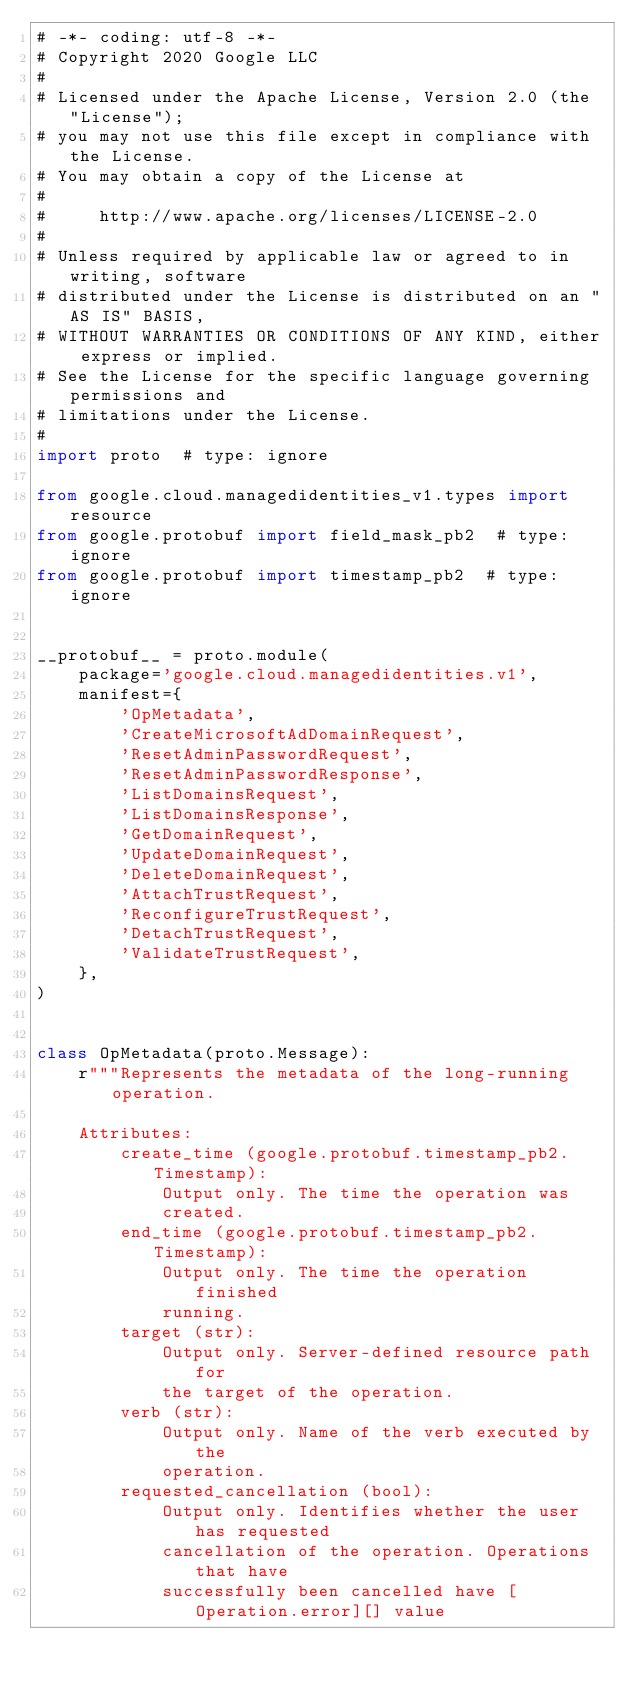Convert code to text. <code><loc_0><loc_0><loc_500><loc_500><_Python_># -*- coding: utf-8 -*-
# Copyright 2020 Google LLC
#
# Licensed under the Apache License, Version 2.0 (the "License");
# you may not use this file except in compliance with the License.
# You may obtain a copy of the License at
#
#     http://www.apache.org/licenses/LICENSE-2.0
#
# Unless required by applicable law or agreed to in writing, software
# distributed under the License is distributed on an "AS IS" BASIS,
# WITHOUT WARRANTIES OR CONDITIONS OF ANY KIND, either express or implied.
# See the License for the specific language governing permissions and
# limitations under the License.
#
import proto  # type: ignore

from google.cloud.managedidentities_v1.types import resource
from google.protobuf import field_mask_pb2  # type: ignore
from google.protobuf import timestamp_pb2  # type: ignore


__protobuf__ = proto.module(
    package='google.cloud.managedidentities.v1',
    manifest={
        'OpMetadata',
        'CreateMicrosoftAdDomainRequest',
        'ResetAdminPasswordRequest',
        'ResetAdminPasswordResponse',
        'ListDomainsRequest',
        'ListDomainsResponse',
        'GetDomainRequest',
        'UpdateDomainRequest',
        'DeleteDomainRequest',
        'AttachTrustRequest',
        'ReconfigureTrustRequest',
        'DetachTrustRequest',
        'ValidateTrustRequest',
    },
)


class OpMetadata(proto.Message):
    r"""Represents the metadata of the long-running operation.

    Attributes:
        create_time (google.protobuf.timestamp_pb2.Timestamp):
            Output only. The time the operation was
            created.
        end_time (google.protobuf.timestamp_pb2.Timestamp):
            Output only. The time the operation finished
            running.
        target (str):
            Output only. Server-defined resource path for
            the target of the operation.
        verb (str):
            Output only. Name of the verb executed by the
            operation.
        requested_cancellation (bool):
            Output only. Identifies whether the user has requested
            cancellation of the operation. Operations that have
            successfully been cancelled have [Operation.error][] value</code> 